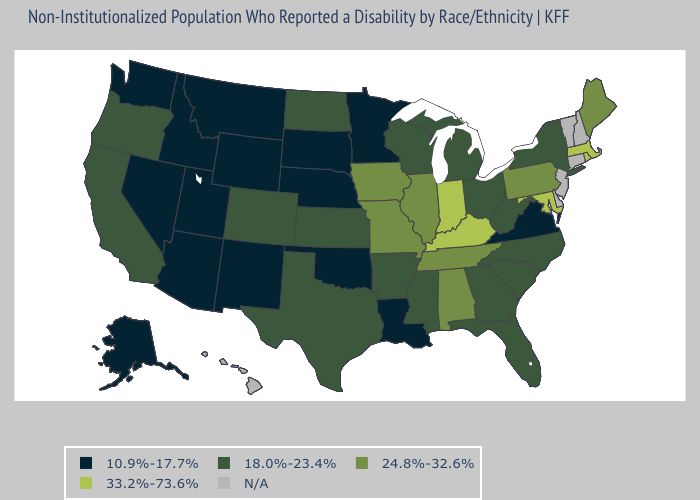Name the states that have a value in the range 24.8%-32.6%?
Give a very brief answer. Alabama, Illinois, Iowa, Maine, Missouri, Pennsylvania, Tennessee. What is the lowest value in the USA?
Answer briefly. 10.9%-17.7%. Name the states that have a value in the range 18.0%-23.4%?
Answer briefly. Arkansas, California, Colorado, Florida, Georgia, Kansas, Michigan, Mississippi, New York, North Carolina, North Dakota, Ohio, Oregon, South Carolina, Texas, West Virginia, Wisconsin. Among the states that border New Hampshire , which have the highest value?
Be succinct. Massachusetts. Among the states that border Florida , which have the lowest value?
Give a very brief answer. Georgia. What is the highest value in the Northeast ?
Quick response, please. 33.2%-73.6%. Among the states that border Vermont , which have the lowest value?
Quick response, please. New York. What is the value of California?
Be succinct. 18.0%-23.4%. Which states hav the highest value in the MidWest?
Concise answer only. Indiana. What is the value of New Mexico?
Keep it brief. 10.9%-17.7%. Name the states that have a value in the range N/A?
Keep it brief. Connecticut, Delaware, Hawaii, New Hampshire, New Jersey, Vermont. Does Alabama have the lowest value in the South?
Quick response, please. No. What is the value of Illinois?
Concise answer only. 24.8%-32.6%. 